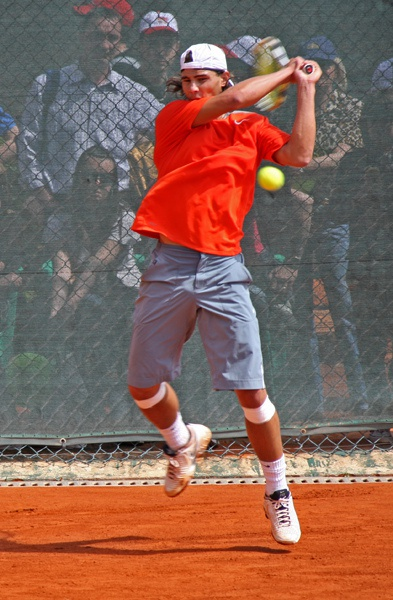Describe the objects in this image and their specific colors. I can see people in gray, red, brown, and white tones, people in gray and darkgray tones, people in gray and darkgray tones, people in gray and darkgray tones, and people in gray, darkgray, and tan tones in this image. 